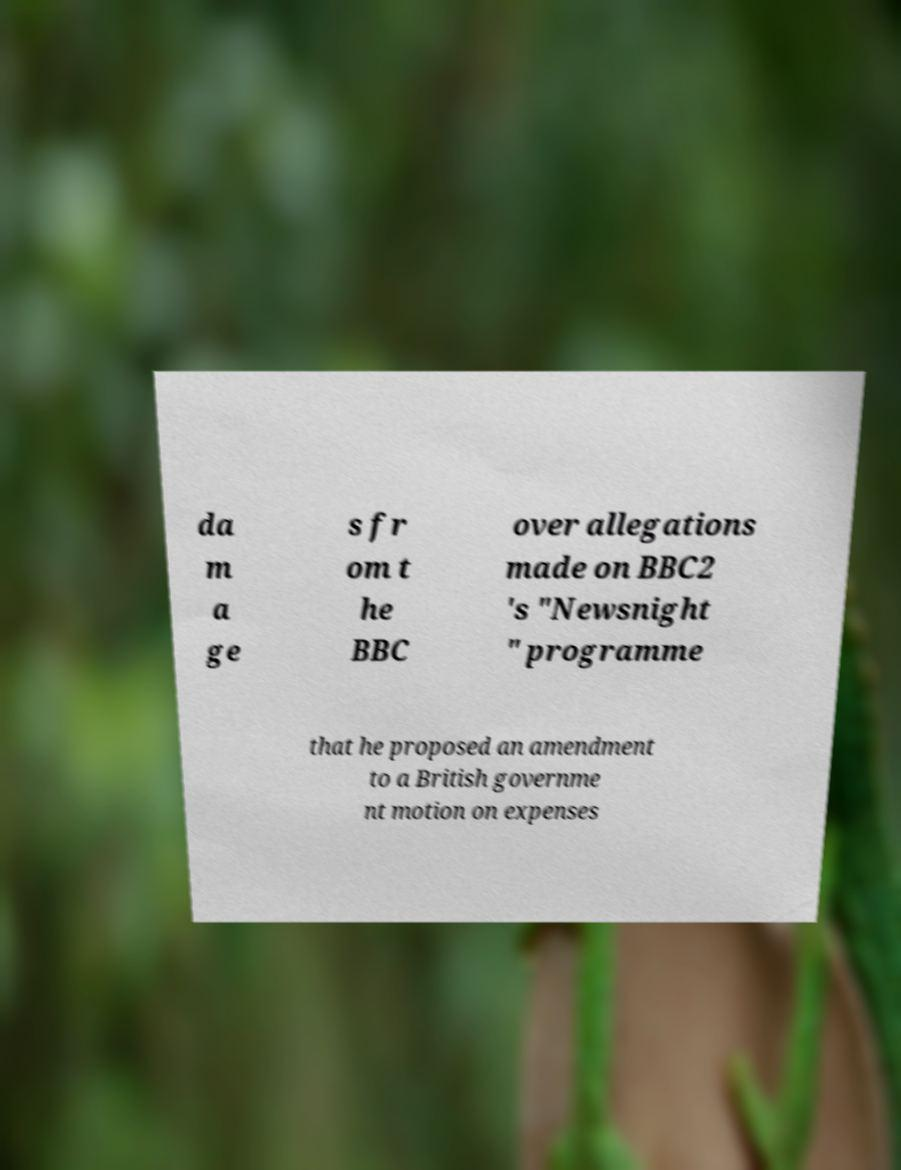I need the written content from this picture converted into text. Can you do that? da m a ge s fr om t he BBC over allegations made on BBC2 's "Newsnight " programme that he proposed an amendment to a British governme nt motion on expenses 